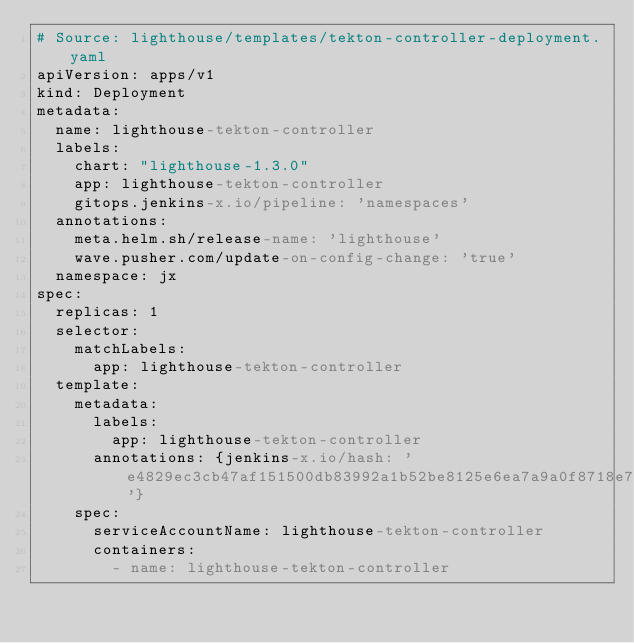Convert code to text. <code><loc_0><loc_0><loc_500><loc_500><_YAML_># Source: lighthouse/templates/tekton-controller-deployment.yaml
apiVersion: apps/v1
kind: Deployment
metadata:
  name: lighthouse-tekton-controller
  labels:
    chart: "lighthouse-1.3.0"
    app: lighthouse-tekton-controller
    gitops.jenkins-x.io/pipeline: 'namespaces'
  annotations:
    meta.helm.sh/release-name: 'lighthouse'
    wave.pusher.com/update-on-config-change: 'true'
  namespace: jx
spec:
  replicas: 1
  selector:
    matchLabels:
      app: lighthouse-tekton-controller
  template:
    metadata:
      labels:
        app: lighthouse-tekton-controller
      annotations: {jenkins-x.io/hash: 'e4829ec3cb47af151500db83992a1b52be8125e6ea7a9a0f8718e723f6a6df0f'}
    spec:
      serviceAccountName: lighthouse-tekton-controller
      containers:
        - name: lighthouse-tekton-controller</code> 